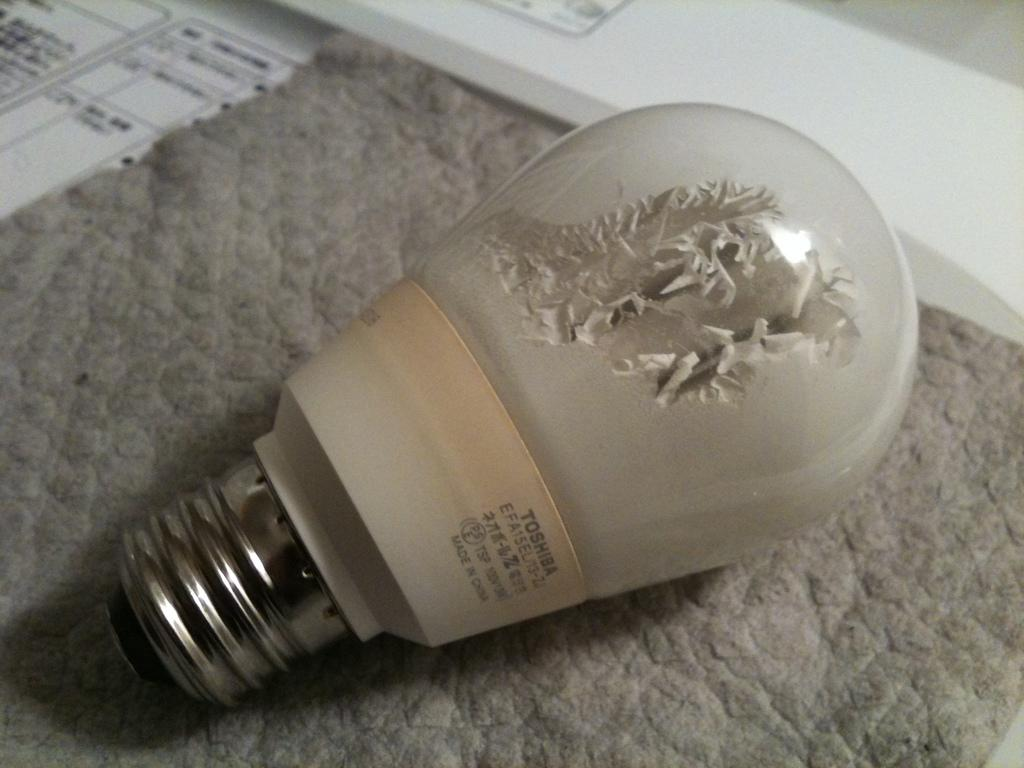What object is placed on a mat in the image? There is a bulb on a mat in the image. What part of the image is not clear or blurred? There is a blurred area at the top of the image. What type of object can be seen in the image besides the bulb? There is a paper in the image. What color is the surface where the bulb and paper are placed? There is a white surface in the image. Reasoning: Let' Let's think step by step in order to produce the conversation. We start by identifying the main subject in the image, which is the bulb on a mat. Then, we describe the blurred area at the top of the image, which is a detail that might be of interest to the viewer. Next, we mention the presence of a paper in the image, which adds more information about the scene. Finally, we describe the color of the surface where the bulb and paper are placed, providing a better understanding of the overall setting. Absurd Question/Answer: How many snakes are slithering on the white surface in the image? There are no snakes present in the image; the white surface only contains a bulb and a paper. 